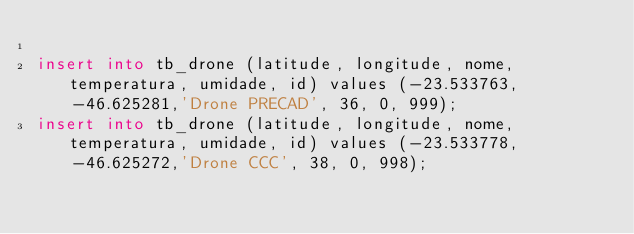<code> <loc_0><loc_0><loc_500><loc_500><_SQL_>
insert into tb_drone (latitude, longitude, nome, temperatura, umidade, id) values (-23.533763, -46.625281,'Drone PRECAD', 36, 0, 999);
insert into tb_drone (latitude, longitude, nome, temperatura, umidade, id) values (-23.533778, -46.625272,'Drone CCC', 38, 0, 998);</code> 